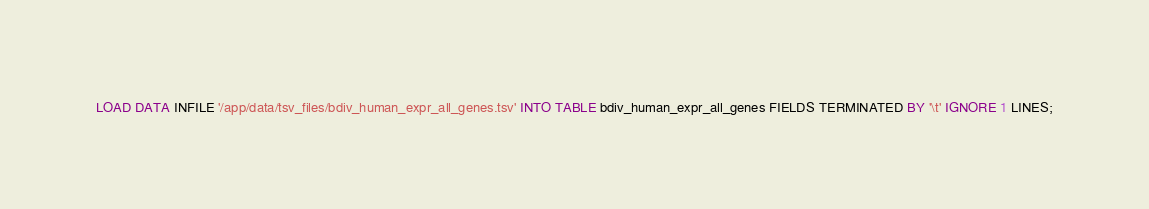Convert code to text. <code><loc_0><loc_0><loc_500><loc_500><_SQL_>LOAD DATA INFILE '/app/data/tsv_files/bdiv_human_expr_all_genes.tsv' INTO TABLE bdiv_human_expr_all_genes FIELDS TERMINATED BY '\t' IGNORE 1 LINES;
</code> 